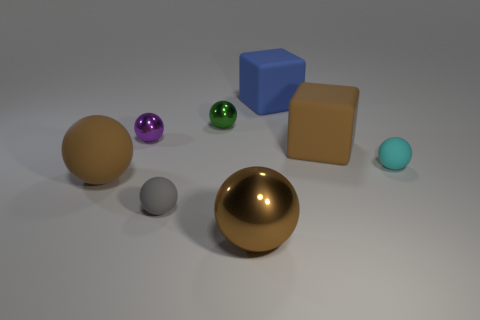Can you tell me what materials the objects may be made of based on their appearance? Based on their appearance, the objects could be made of various materials. The brown and gold spheres give off a reflective, metallic sheen, suggesting they could be made of metal. The blue cube looks plastic due to its matte finish, while the purple and green spheres have a lustrous finish that could imply a glass or glazed ceramic material. The tan-colored cube and the smaller, pale blue sphere also have matte finishes, which could indicate clay, stone or painted wood. 